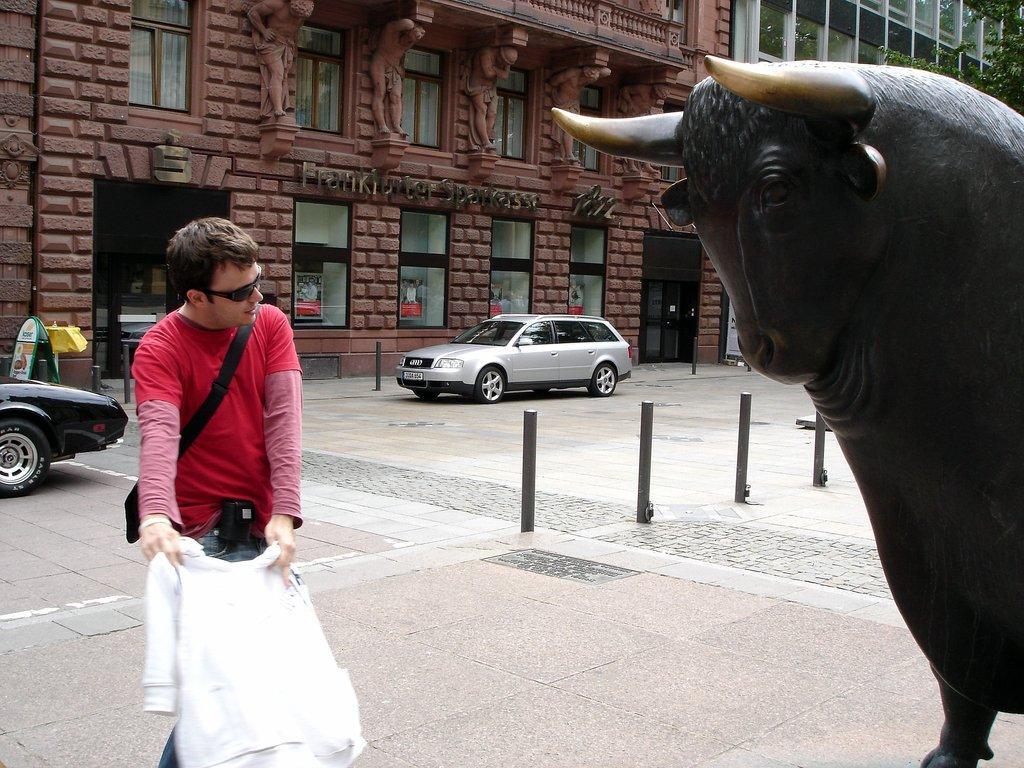Please provide a concise description of this image. In this image I can see a black colour sculpture of a bull. I can also see a man is standing and holding white cloth. I can see she is wearing red t shirt, black shades and carrying a bag. In the background I can see few poles, few cars, buildings, a tree, windows and few boards. On this board I can see something is written. 